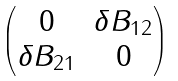<formula> <loc_0><loc_0><loc_500><loc_500>\begin{pmatrix} 0 & \delta B _ { 1 2 } \\ \delta B _ { 2 1 } & 0 \end{pmatrix}</formula> 